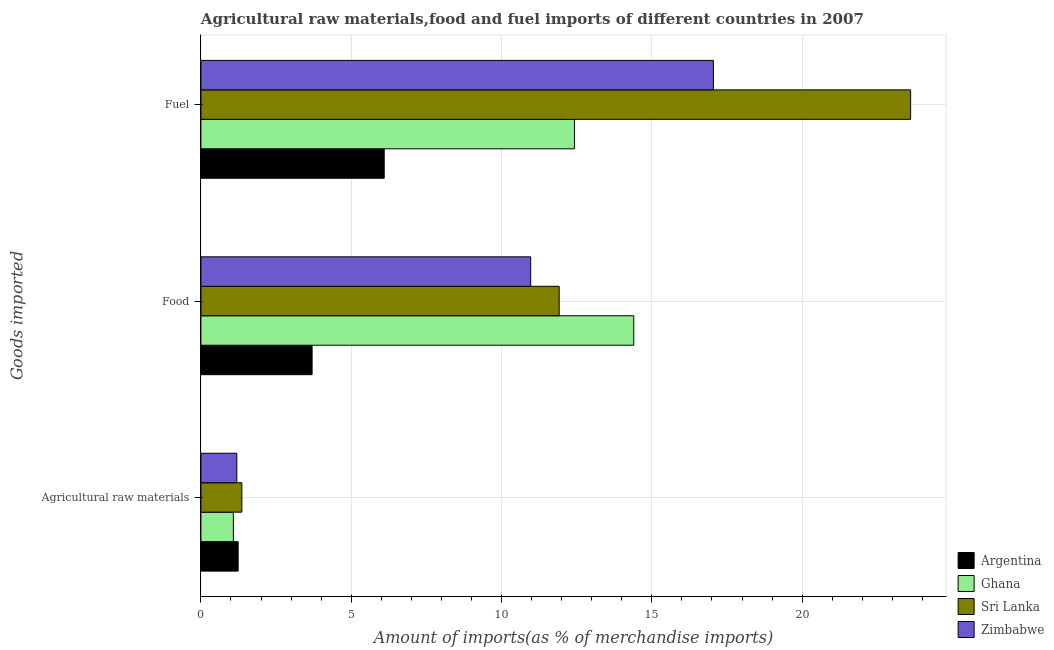How many different coloured bars are there?
Your answer should be compact. 4. How many groups of bars are there?
Give a very brief answer. 3. How many bars are there on the 1st tick from the top?
Your answer should be very brief. 4. How many bars are there on the 3rd tick from the bottom?
Your response must be concise. 4. What is the label of the 3rd group of bars from the top?
Ensure brevity in your answer.  Agricultural raw materials. What is the percentage of raw materials imports in Ghana?
Your response must be concise. 1.08. Across all countries, what is the maximum percentage of fuel imports?
Keep it short and to the point. 23.61. Across all countries, what is the minimum percentage of fuel imports?
Provide a succinct answer. 6.1. In which country was the percentage of raw materials imports maximum?
Provide a short and direct response. Sri Lanka. What is the total percentage of raw materials imports in the graph?
Make the answer very short. 4.87. What is the difference between the percentage of raw materials imports in Ghana and that in Zimbabwe?
Your answer should be compact. -0.12. What is the difference between the percentage of food imports in Ghana and the percentage of raw materials imports in Zimbabwe?
Provide a short and direct response. 13.2. What is the average percentage of fuel imports per country?
Your response must be concise. 14.79. What is the difference between the percentage of food imports and percentage of fuel imports in Sri Lanka?
Keep it short and to the point. -11.69. What is the ratio of the percentage of food imports in Zimbabwe to that in Sri Lanka?
Offer a terse response. 0.92. Is the percentage of raw materials imports in Ghana less than that in Sri Lanka?
Your response must be concise. Yes. Is the difference between the percentage of fuel imports in Sri Lanka and Ghana greater than the difference between the percentage of food imports in Sri Lanka and Ghana?
Make the answer very short. Yes. What is the difference between the highest and the second highest percentage of food imports?
Offer a terse response. 2.48. What is the difference between the highest and the lowest percentage of raw materials imports?
Keep it short and to the point. 0.28. In how many countries, is the percentage of raw materials imports greater than the average percentage of raw materials imports taken over all countries?
Give a very brief answer. 2. Is the sum of the percentage of food imports in Ghana and Argentina greater than the maximum percentage of raw materials imports across all countries?
Ensure brevity in your answer.  Yes. What does the 2nd bar from the bottom in Agricultural raw materials represents?
Offer a very short reply. Ghana. Are all the bars in the graph horizontal?
Give a very brief answer. Yes. What is the difference between two consecutive major ticks on the X-axis?
Keep it short and to the point. 5. Are the values on the major ticks of X-axis written in scientific E-notation?
Provide a succinct answer. No. Does the graph contain grids?
Offer a very short reply. Yes. How are the legend labels stacked?
Provide a succinct answer. Vertical. What is the title of the graph?
Your response must be concise. Agricultural raw materials,food and fuel imports of different countries in 2007. What is the label or title of the X-axis?
Give a very brief answer. Amount of imports(as % of merchandise imports). What is the label or title of the Y-axis?
Offer a very short reply. Goods imported. What is the Amount of imports(as % of merchandise imports) of Argentina in Agricultural raw materials?
Your response must be concise. 1.24. What is the Amount of imports(as % of merchandise imports) of Ghana in Agricultural raw materials?
Provide a short and direct response. 1.08. What is the Amount of imports(as % of merchandise imports) of Sri Lanka in Agricultural raw materials?
Provide a short and direct response. 1.36. What is the Amount of imports(as % of merchandise imports) in Zimbabwe in Agricultural raw materials?
Offer a very short reply. 1.19. What is the Amount of imports(as % of merchandise imports) of Argentina in Food?
Provide a succinct answer. 3.7. What is the Amount of imports(as % of merchandise imports) in Ghana in Food?
Provide a succinct answer. 14.4. What is the Amount of imports(as % of merchandise imports) in Sri Lanka in Food?
Offer a very short reply. 11.92. What is the Amount of imports(as % of merchandise imports) in Zimbabwe in Food?
Keep it short and to the point. 10.97. What is the Amount of imports(as % of merchandise imports) of Argentina in Fuel?
Keep it short and to the point. 6.1. What is the Amount of imports(as % of merchandise imports) of Ghana in Fuel?
Offer a very short reply. 12.43. What is the Amount of imports(as % of merchandise imports) of Sri Lanka in Fuel?
Keep it short and to the point. 23.61. What is the Amount of imports(as % of merchandise imports) in Zimbabwe in Fuel?
Provide a short and direct response. 17.05. Across all Goods imported, what is the maximum Amount of imports(as % of merchandise imports) of Argentina?
Offer a very short reply. 6.1. Across all Goods imported, what is the maximum Amount of imports(as % of merchandise imports) of Ghana?
Ensure brevity in your answer.  14.4. Across all Goods imported, what is the maximum Amount of imports(as % of merchandise imports) in Sri Lanka?
Offer a very short reply. 23.61. Across all Goods imported, what is the maximum Amount of imports(as % of merchandise imports) in Zimbabwe?
Give a very brief answer. 17.05. Across all Goods imported, what is the minimum Amount of imports(as % of merchandise imports) of Argentina?
Ensure brevity in your answer.  1.24. Across all Goods imported, what is the minimum Amount of imports(as % of merchandise imports) of Ghana?
Ensure brevity in your answer.  1.08. Across all Goods imported, what is the minimum Amount of imports(as % of merchandise imports) in Sri Lanka?
Your response must be concise. 1.36. Across all Goods imported, what is the minimum Amount of imports(as % of merchandise imports) of Zimbabwe?
Keep it short and to the point. 1.19. What is the total Amount of imports(as % of merchandise imports) in Argentina in the graph?
Keep it short and to the point. 11.03. What is the total Amount of imports(as % of merchandise imports) in Ghana in the graph?
Your response must be concise. 27.9. What is the total Amount of imports(as % of merchandise imports) in Sri Lanka in the graph?
Offer a terse response. 36.89. What is the total Amount of imports(as % of merchandise imports) of Zimbabwe in the graph?
Make the answer very short. 29.21. What is the difference between the Amount of imports(as % of merchandise imports) in Argentina in Agricultural raw materials and that in Food?
Provide a short and direct response. -2.46. What is the difference between the Amount of imports(as % of merchandise imports) of Ghana in Agricultural raw materials and that in Food?
Your answer should be compact. -13.32. What is the difference between the Amount of imports(as % of merchandise imports) in Sri Lanka in Agricultural raw materials and that in Food?
Provide a short and direct response. -10.56. What is the difference between the Amount of imports(as % of merchandise imports) in Zimbabwe in Agricultural raw materials and that in Food?
Ensure brevity in your answer.  -9.78. What is the difference between the Amount of imports(as % of merchandise imports) in Argentina in Agricultural raw materials and that in Fuel?
Provide a succinct answer. -4.86. What is the difference between the Amount of imports(as % of merchandise imports) of Ghana in Agricultural raw materials and that in Fuel?
Keep it short and to the point. -11.35. What is the difference between the Amount of imports(as % of merchandise imports) of Sri Lanka in Agricultural raw materials and that in Fuel?
Give a very brief answer. -22.25. What is the difference between the Amount of imports(as % of merchandise imports) in Zimbabwe in Agricultural raw materials and that in Fuel?
Keep it short and to the point. -15.85. What is the difference between the Amount of imports(as % of merchandise imports) of Argentina in Food and that in Fuel?
Give a very brief answer. -2.4. What is the difference between the Amount of imports(as % of merchandise imports) in Ghana in Food and that in Fuel?
Give a very brief answer. 1.97. What is the difference between the Amount of imports(as % of merchandise imports) of Sri Lanka in Food and that in Fuel?
Your response must be concise. -11.69. What is the difference between the Amount of imports(as % of merchandise imports) of Zimbabwe in Food and that in Fuel?
Your response must be concise. -6.08. What is the difference between the Amount of imports(as % of merchandise imports) of Argentina in Agricultural raw materials and the Amount of imports(as % of merchandise imports) of Ghana in Food?
Provide a succinct answer. -13.16. What is the difference between the Amount of imports(as % of merchandise imports) in Argentina in Agricultural raw materials and the Amount of imports(as % of merchandise imports) in Sri Lanka in Food?
Your response must be concise. -10.68. What is the difference between the Amount of imports(as % of merchandise imports) in Argentina in Agricultural raw materials and the Amount of imports(as % of merchandise imports) in Zimbabwe in Food?
Your answer should be compact. -9.73. What is the difference between the Amount of imports(as % of merchandise imports) in Ghana in Agricultural raw materials and the Amount of imports(as % of merchandise imports) in Sri Lanka in Food?
Keep it short and to the point. -10.84. What is the difference between the Amount of imports(as % of merchandise imports) of Ghana in Agricultural raw materials and the Amount of imports(as % of merchandise imports) of Zimbabwe in Food?
Offer a terse response. -9.89. What is the difference between the Amount of imports(as % of merchandise imports) in Sri Lanka in Agricultural raw materials and the Amount of imports(as % of merchandise imports) in Zimbabwe in Food?
Provide a short and direct response. -9.61. What is the difference between the Amount of imports(as % of merchandise imports) in Argentina in Agricultural raw materials and the Amount of imports(as % of merchandise imports) in Ghana in Fuel?
Your response must be concise. -11.19. What is the difference between the Amount of imports(as % of merchandise imports) in Argentina in Agricultural raw materials and the Amount of imports(as % of merchandise imports) in Sri Lanka in Fuel?
Provide a short and direct response. -22.37. What is the difference between the Amount of imports(as % of merchandise imports) in Argentina in Agricultural raw materials and the Amount of imports(as % of merchandise imports) in Zimbabwe in Fuel?
Your response must be concise. -15.81. What is the difference between the Amount of imports(as % of merchandise imports) in Ghana in Agricultural raw materials and the Amount of imports(as % of merchandise imports) in Sri Lanka in Fuel?
Keep it short and to the point. -22.53. What is the difference between the Amount of imports(as % of merchandise imports) of Ghana in Agricultural raw materials and the Amount of imports(as % of merchandise imports) of Zimbabwe in Fuel?
Offer a very short reply. -15.97. What is the difference between the Amount of imports(as % of merchandise imports) of Sri Lanka in Agricultural raw materials and the Amount of imports(as % of merchandise imports) of Zimbabwe in Fuel?
Keep it short and to the point. -15.68. What is the difference between the Amount of imports(as % of merchandise imports) of Argentina in Food and the Amount of imports(as % of merchandise imports) of Ghana in Fuel?
Offer a terse response. -8.73. What is the difference between the Amount of imports(as % of merchandise imports) of Argentina in Food and the Amount of imports(as % of merchandise imports) of Sri Lanka in Fuel?
Keep it short and to the point. -19.91. What is the difference between the Amount of imports(as % of merchandise imports) in Argentina in Food and the Amount of imports(as % of merchandise imports) in Zimbabwe in Fuel?
Your response must be concise. -13.35. What is the difference between the Amount of imports(as % of merchandise imports) of Ghana in Food and the Amount of imports(as % of merchandise imports) of Sri Lanka in Fuel?
Your response must be concise. -9.21. What is the difference between the Amount of imports(as % of merchandise imports) of Ghana in Food and the Amount of imports(as % of merchandise imports) of Zimbabwe in Fuel?
Offer a very short reply. -2.65. What is the difference between the Amount of imports(as % of merchandise imports) in Sri Lanka in Food and the Amount of imports(as % of merchandise imports) in Zimbabwe in Fuel?
Give a very brief answer. -5.13. What is the average Amount of imports(as % of merchandise imports) in Argentina per Goods imported?
Provide a succinct answer. 3.68. What is the average Amount of imports(as % of merchandise imports) in Ghana per Goods imported?
Provide a short and direct response. 9.3. What is the average Amount of imports(as % of merchandise imports) in Sri Lanka per Goods imported?
Offer a very short reply. 12.3. What is the average Amount of imports(as % of merchandise imports) of Zimbabwe per Goods imported?
Offer a very short reply. 9.74. What is the difference between the Amount of imports(as % of merchandise imports) of Argentina and Amount of imports(as % of merchandise imports) of Ghana in Agricultural raw materials?
Make the answer very short. 0.16. What is the difference between the Amount of imports(as % of merchandise imports) of Argentina and Amount of imports(as % of merchandise imports) of Sri Lanka in Agricultural raw materials?
Provide a succinct answer. -0.12. What is the difference between the Amount of imports(as % of merchandise imports) of Argentina and Amount of imports(as % of merchandise imports) of Zimbabwe in Agricultural raw materials?
Your response must be concise. 0.04. What is the difference between the Amount of imports(as % of merchandise imports) of Ghana and Amount of imports(as % of merchandise imports) of Sri Lanka in Agricultural raw materials?
Keep it short and to the point. -0.28. What is the difference between the Amount of imports(as % of merchandise imports) in Ghana and Amount of imports(as % of merchandise imports) in Zimbabwe in Agricultural raw materials?
Offer a terse response. -0.12. What is the difference between the Amount of imports(as % of merchandise imports) of Sri Lanka and Amount of imports(as % of merchandise imports) of Zimbabwe in Agricultural raw materials?
Your answer should be compact. 0.17. What is the difference between the Amount of imports(as % of merchandise imports) in Argentina and Amount of imports(as % of merchandise imports) in Ghana in Food?
Offer a very short reply. -10.7. What is the difference between the Amount of imports(as % of merchandise imports) in Argentina and Amount of imports(as % of merchandise imports) in Sri Lanka in Food?
Your response must be concise. -8.22. What is the difference between the Amount of imports(as % of merchandise imports) of Argentina and Amount of imports(as % of merchandise imports) of Zimbabwe in Food?
Your response must be concise. -7.27. What is the difference between the Amount of imports(as % of merchandise imports) in Ghana and Amount of imports(as % of merchandise imports) in Sri Lanka in Food?
Provide a succinct answer. 2.48. What is the difference between the Amount of imports(as % of merchandise imports) of Ghana and Amount of imports(as % of merchandise imports) of Zimbabwe in Food?
Offer a very short reply. 3.43. What is the difference between the Amount of imports(as % of merchandise imports) of Sri Lanka and Amount of imports(as % of merchandise imports) of Zimbabwe in Food?
Your response must be concise. 0.95. What is the difference between the Amount of imports(as % of merchandise imports) of Argentina and Amount of imports(as % of merchandise imports) of Ghana in Fuel?
Provide a succinct answer. -6.33. What is the difference between the Amount of imports(as % of merchandise imports) in Argentina and Amount of imports(as % of merchandise imports) in Sri Lanka in Fuel?
Provide a succinct answer. -17.51. What is the difference between the Amount of imports(as % of merchandise imports) in Argentina and Amount of imports(as % of merchandise imports) in Zimbabwe in Fuel?
Your answer should be compact. -10.95. What is the difference between the Amount of imports(as % of merchandise imports) of Ghana and Amount of imports(as % of merchandise imports) of Sri Lanka in Fuel?
Provide a short and direct response. -11.18. What is the difference between the Amount of imports(as % of merchandise imports) of Ghana and Amount of imports(as % of merchandise imports) of Zimbabwe in Fuel?
Keep it short and to the point. -4.62. What is the difference between the Amount of imports(as % of merchandise imports) of Sri Lanka and Amount of imports(as % of merchandise imports) of Zimbabwe in Fuel?
Ensure brevity in your answer.  6.56. What is the ratio of the Amount of imports(as % of merchandise imports) of Argentina in Agricultural raw materials to that in Food?
Keep it short and to the point. 0.33. What is the ratio of the Amount of imports(as % of merchandise imports) of Ghana in Agricultural raw materials to that in Food?
Your answer should be very brief. 0.07. What is the ratio of the Amount of imports(as % of merchandise imports) of Sri Lanka in Agricultural raw materials to that in Food?
Keep it short and to the point. 0.11. What is the ratio of the Amount of imports(as % of merchandise imports) in Zimbabwe in Agricultural raw materials to that in Food?
Provide a short and direct response. 0.11. What is the ratio of the Amount of imports(as % of merchandise imports) of Argentina in Agricultural raw materials to that in Fuel?
Offer a very short reply. 0.2. What is the ratio of the Amount of imports(as % of merchandise imports) of Ghana in Agricultural raw materials to that in Fuel?
Provide a succinct answer. 0.09. What is the ratio of the Amount of imports(as % of merchandise imports) of Sri Lanka in Agricultural raw materials to that in Fuel?
Your answer should be compact. 0.06. What is the ratio of the Amount of imports(as % of merchandise imports) of Zimbabwe in Agricultural raw materials to that in Fuel?
Your response must be concise. 0.07. What is the ratio of the Amount of imports(as % of merchandise imports) in Argentina in Food to that in Fuel?
Ensure brevity in your answer.  0.61. What is the ratio of the Amount of imports(as % of merchandise imports) in Ghana in Food to that in Fuel?
Give a very brief answer. 1.16. What is the ratio of the Amount of imports(as % of merchandise imports) of Sri Lanka in Food to that in Fuel?
Your response must be concise. 0.5. What is the ratio of the Amount of imports(as % of merchandise imports) of Zimbabwe in Food to that in Fuel?
Your answer should be compact. 0.64. What is the difference between the highest and the second highest Amount of imports(as % of merchandise imports) of Argentina?
Offer a very short reply. 2.4. What is the difference between the highest and the second highest Amount of imports(as % of merchandise imports) of Ghana?
Provide a succinct answer. 1.97. What is the difference between the highest and the second highest Amount of imports(as % of merchandise imports) of Sri Lanka?
Your answer should be compact. 11.69. What is the difference between the highest and the second highest Amount of imports(as % of merchandise imports) of Zimbabwe?
Make the answer very short. 6.08. What is the difference between the highest and the lowest Amount of imports(as % of merchandise imports) of Argentina?
Keep it short and to the point. 4.86. What is the difference between the highest and the lowest Amount of imports(as % of merchandise imports) in Ghana?
Your answer should be compact. 13.32. What is the difference between the highest and the lowest Amount of imports(as % of merchandise imports) in Sri Lanka?
Provide a short and direct response. 22.25. What is the difference between the highest and the lowest Amount of imports(as % of merchandise imports) of Zimbabwe?
Give a very brief answer. 15.85. 